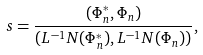Convert formula to latex. <formula><loc_0><loc_0><loc_500><loc_500>s = \frac { ( \Phi ^ { \ast } _ { n } , \Phi _ { n } ) } { ( L ^ { - 1 } N ( \Phi _ { n } ^ { \ast } ) , L ^ { - 1 } N ( \Phi _ { n } ) ) } ,</formula> 